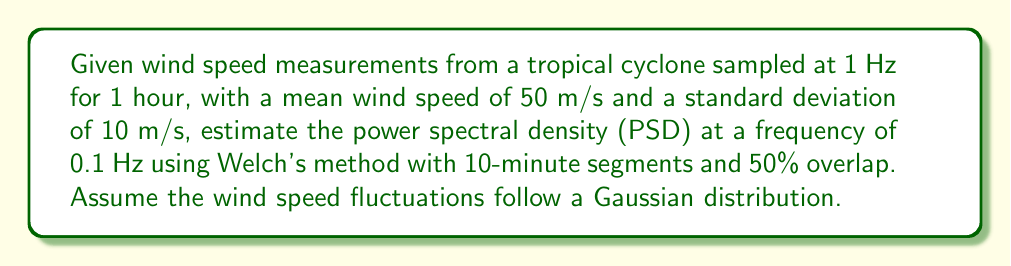Solve this math problem. To estimate the power spectral density (PSD) using Welch's method:

1. Calculate the number of segments:
   - Total duration = 3600 seconds
   - Segment duration = 600 seconds (10 minutes)
   - Number of segments with 50% overlap = $\frac{3600-300}{300} = 11$ segments

2. For each segment, compute the periodogram:
   $P_i(f) = \frac{1}{N}|\sum_{n=0}^{N-1} x_n e^{-j2\pi fn}|^2$
   where $N$ is the number of points in each segment (600 in this case).

3. Average the periodograms:
   $PSD(f) = \frac{1}{K}\sum_{i=1}^K P_i(f)$
   where $K$ is the number of segments (11 in this case).

4. For Gaussian-distributed wind speed fluctuations, the PSD follows a theoretical model:
   $S(f) = \frac{4\sigma^2 \tau}{1 + (2\pi f \tau)^2}$
   where $\sigma$ is the standard deviation and $\tau$ is the integral time scale.

5. Estimate $\tau$ using the von Kármán spectrum:
   $\tau \approx \frac{L_u}{\bar{U}}$
   where $L_u$ is the longitudinal integral length scale (typically 100-1000 m for tropical cyclones) and $\bar{U}$ is the mean wind speed.

6. Using $L_u = 500$ m and $\bar{U} = 50$ m/s:
   $\tau = \frac{500}{50} = 10$ seconds

7. Calculate the PSD at $f = 0.1$ Hz:
   $S(0.1) = \frac{4 \cdot 10^2 \cdot 10}{1 + (2\pi \cdot 0.1 \cdot 10)^2} = \frac{4000}{1 + 39.48} \approx 98.77$ m²/s

The estimated PSD at 0.1 Hz is approximately 98.77 m²/s.
Answer: 98.77 m²/s 